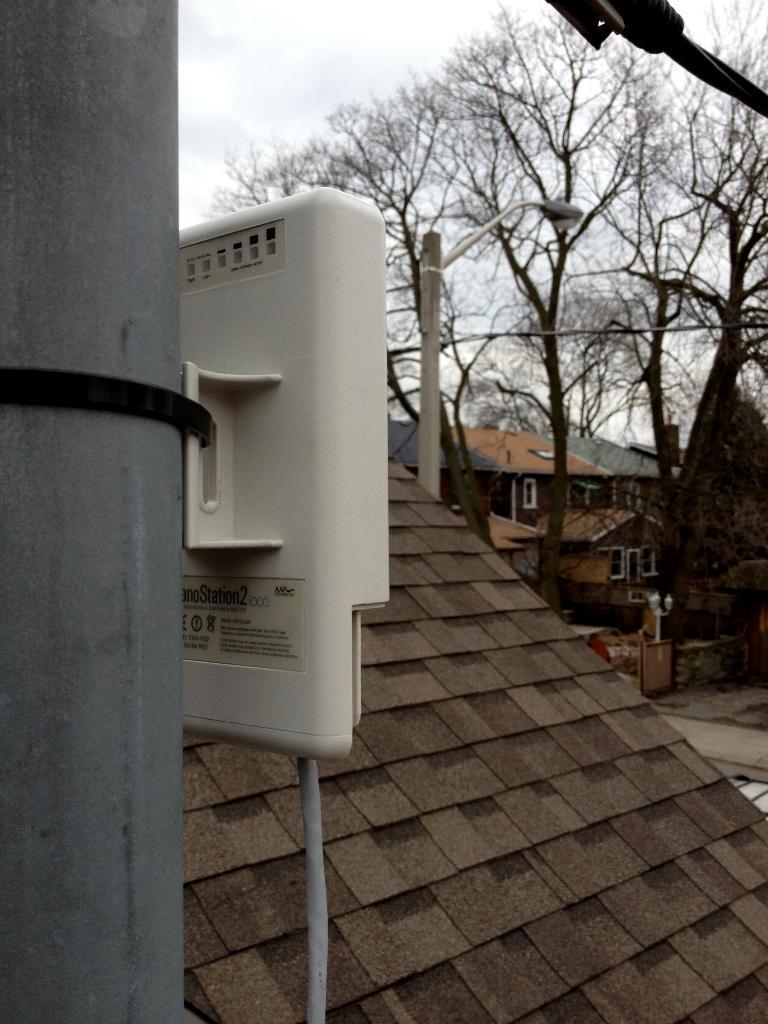How would you summarize this image in a sentence or two? In this picture I can see a pole in front and I can see a white color thing attached to it and I can see the roof of a building. In the background I can see few trees, a light pole, few buildings and the sky. On the top right corner of this picture I can see a black color thing. 